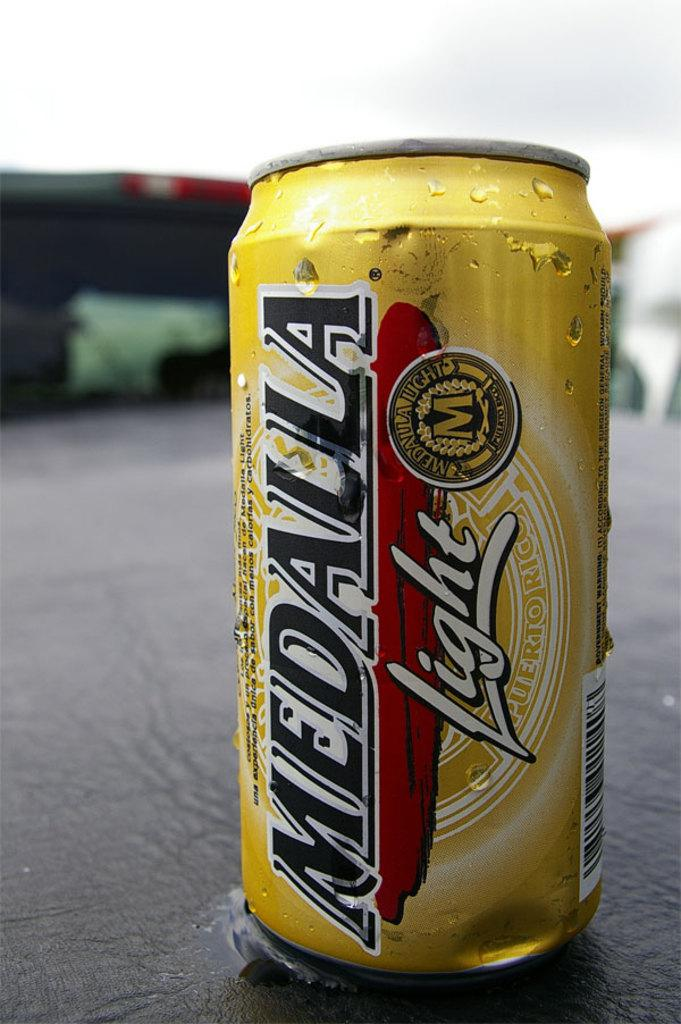<image>
Summarize the visual content of the image. A yellow can with a red banner says Medalla light in white letters. 